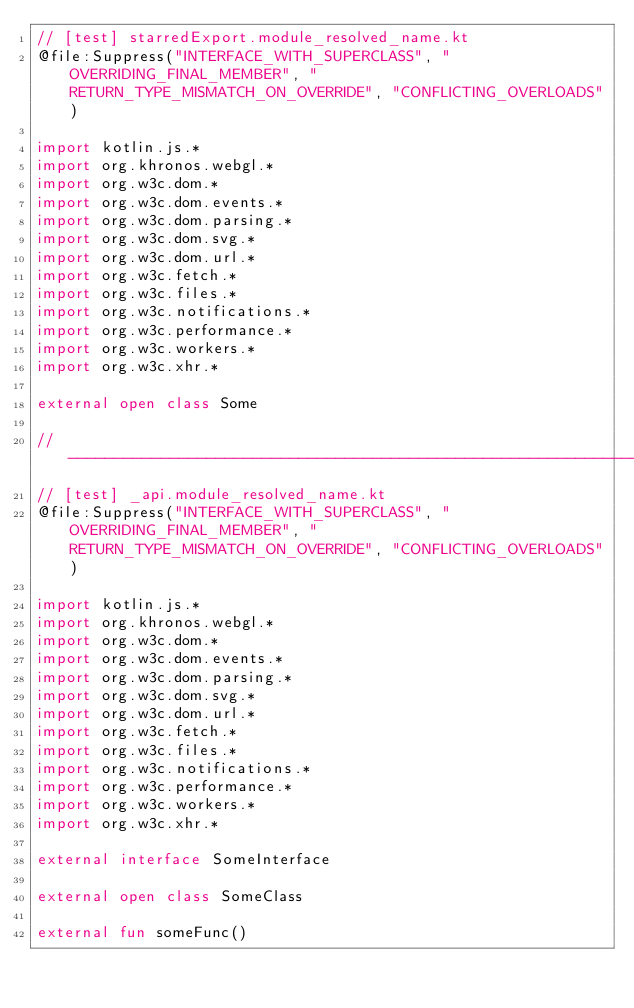Convert code to text. <code><loc_0><loc_0><loc_500><loc_500><_Kotlin_>// [test] starredExport.module_resolved_name.kt
@file:Suppress("INTERFACE_WITH_SUPERCLASS", "OVERRIDING_FINAL_MEMBER", "RETURN_TYPE_MISMATCH_ON_OVERRIDE", "CONFLICTING_OVERLOADS")

import kotlin.js.*
import org.khronos.webgl.*
import org.w3c.dom.*
import org.w3c.dom.events.*
import org.w3c.dom.parsing.*
import org.w3c.dom.svg.*
import org.w3c.dom.url.*
import org.w3c.fetch.*
import org.w3c.files.*
import org.w3c.notifications.*
import org.w3c.performance.*
import org.w3c.workers.*
import org.w3c.xhr.*

external open class Some

// ------------------------------------------------------------------------------------------
// [test] _api.module_resolved_name.kt
@file:Suppress("INTERFACE_WITH_SUPERCLASS", "OVERRIDING_FINAL_MEMBER", "RETURN_TYPE_MISMATCH_ON_OVERRIDE", "CONFLICTING_OVERLOADS")

import kotlin.js.*
import org.khronos.webgl.*
import org.w3c.dom.*
import org.w3c.dom.events.*
import org.w3c.dom.parsing.*
import org.w3c.dom.svg.*
import org.w3c.dom.url.*
import org.w3c.fetch.*
import org.w3c.files.*
import org.w3c.notifications.*
import org.w3c.performance.*
import org.w3c.workers.*
import org.w3c.xhr.*

external interface SomeInterface

external open class SomeClass

external fun someFunc()</code> 